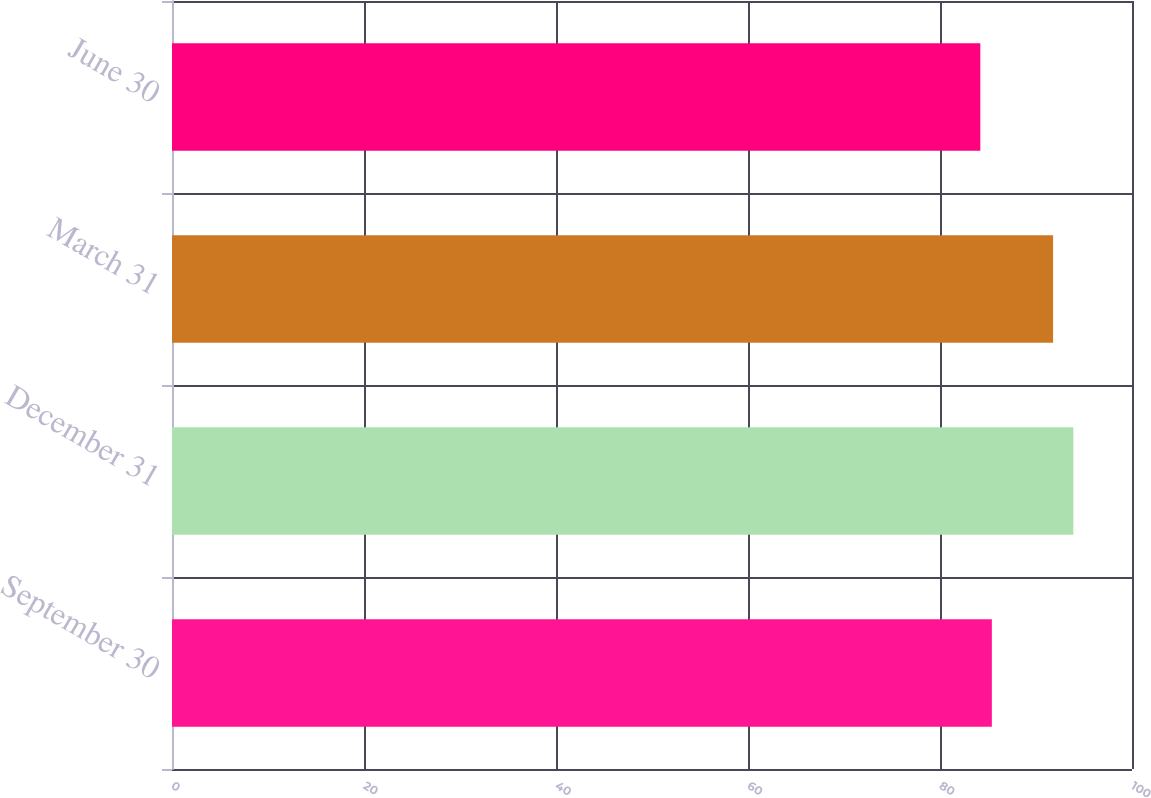<chart> <loc_0><loc_0><loc_500><loc_500><bar_chart><fcel>September 30<fcel>December 31<fcel>March 31<fcel>June 30<nl><fcel>85.4<fcel>93.89<fcel>91.78<fcel>84.2<nl></chart> 